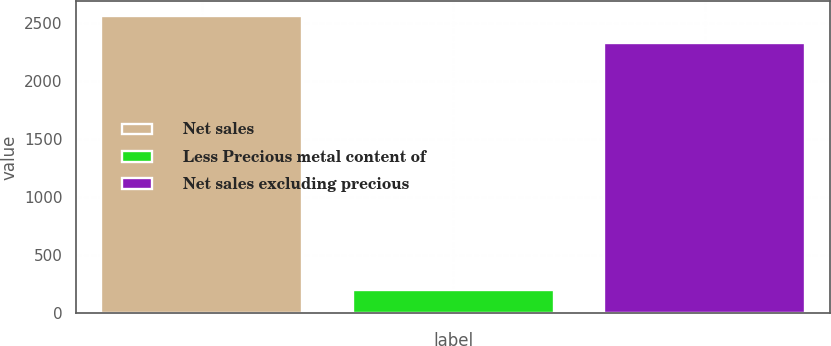Convert chart. <chart><loc_0><loc_0><loc_500><loc_500><bar_chart><fcel>Net sales<fcel>Less Precious metal content of<fcel>Net sales excluding precious<nl><fcel>2565.86<fcel>205.1<fcel>2332.6<nl></chart> 